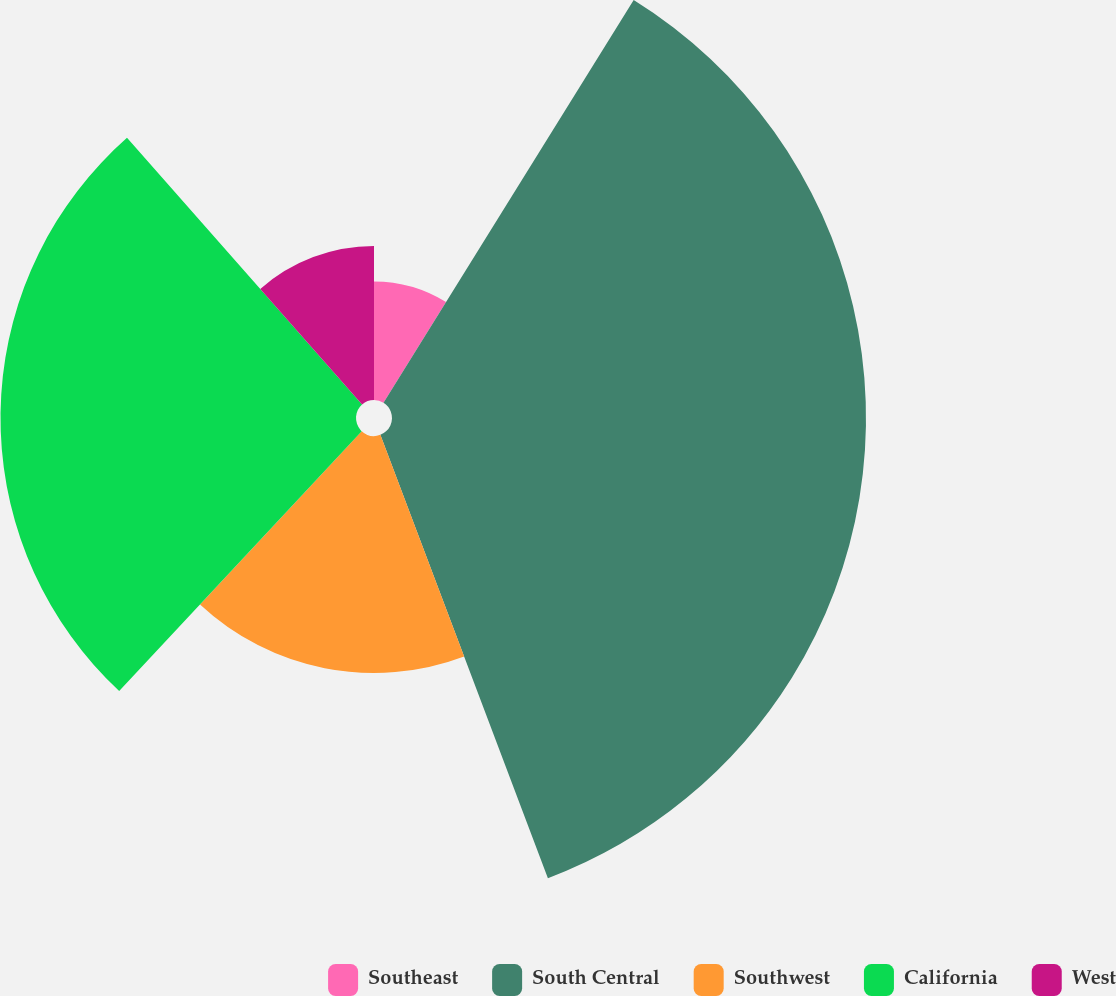<chart> <loc_0><loc_0><loc_500><loc_500><pie_chart><fcel>Southeast<fcel>South Central<fcel>Southwest<fcel>California<fcel>West<nl><fcel>8.85%<fcel>35.4%<fcel>17.7%<fcel>26.55%<fcel>11.5%<nl></chart> 